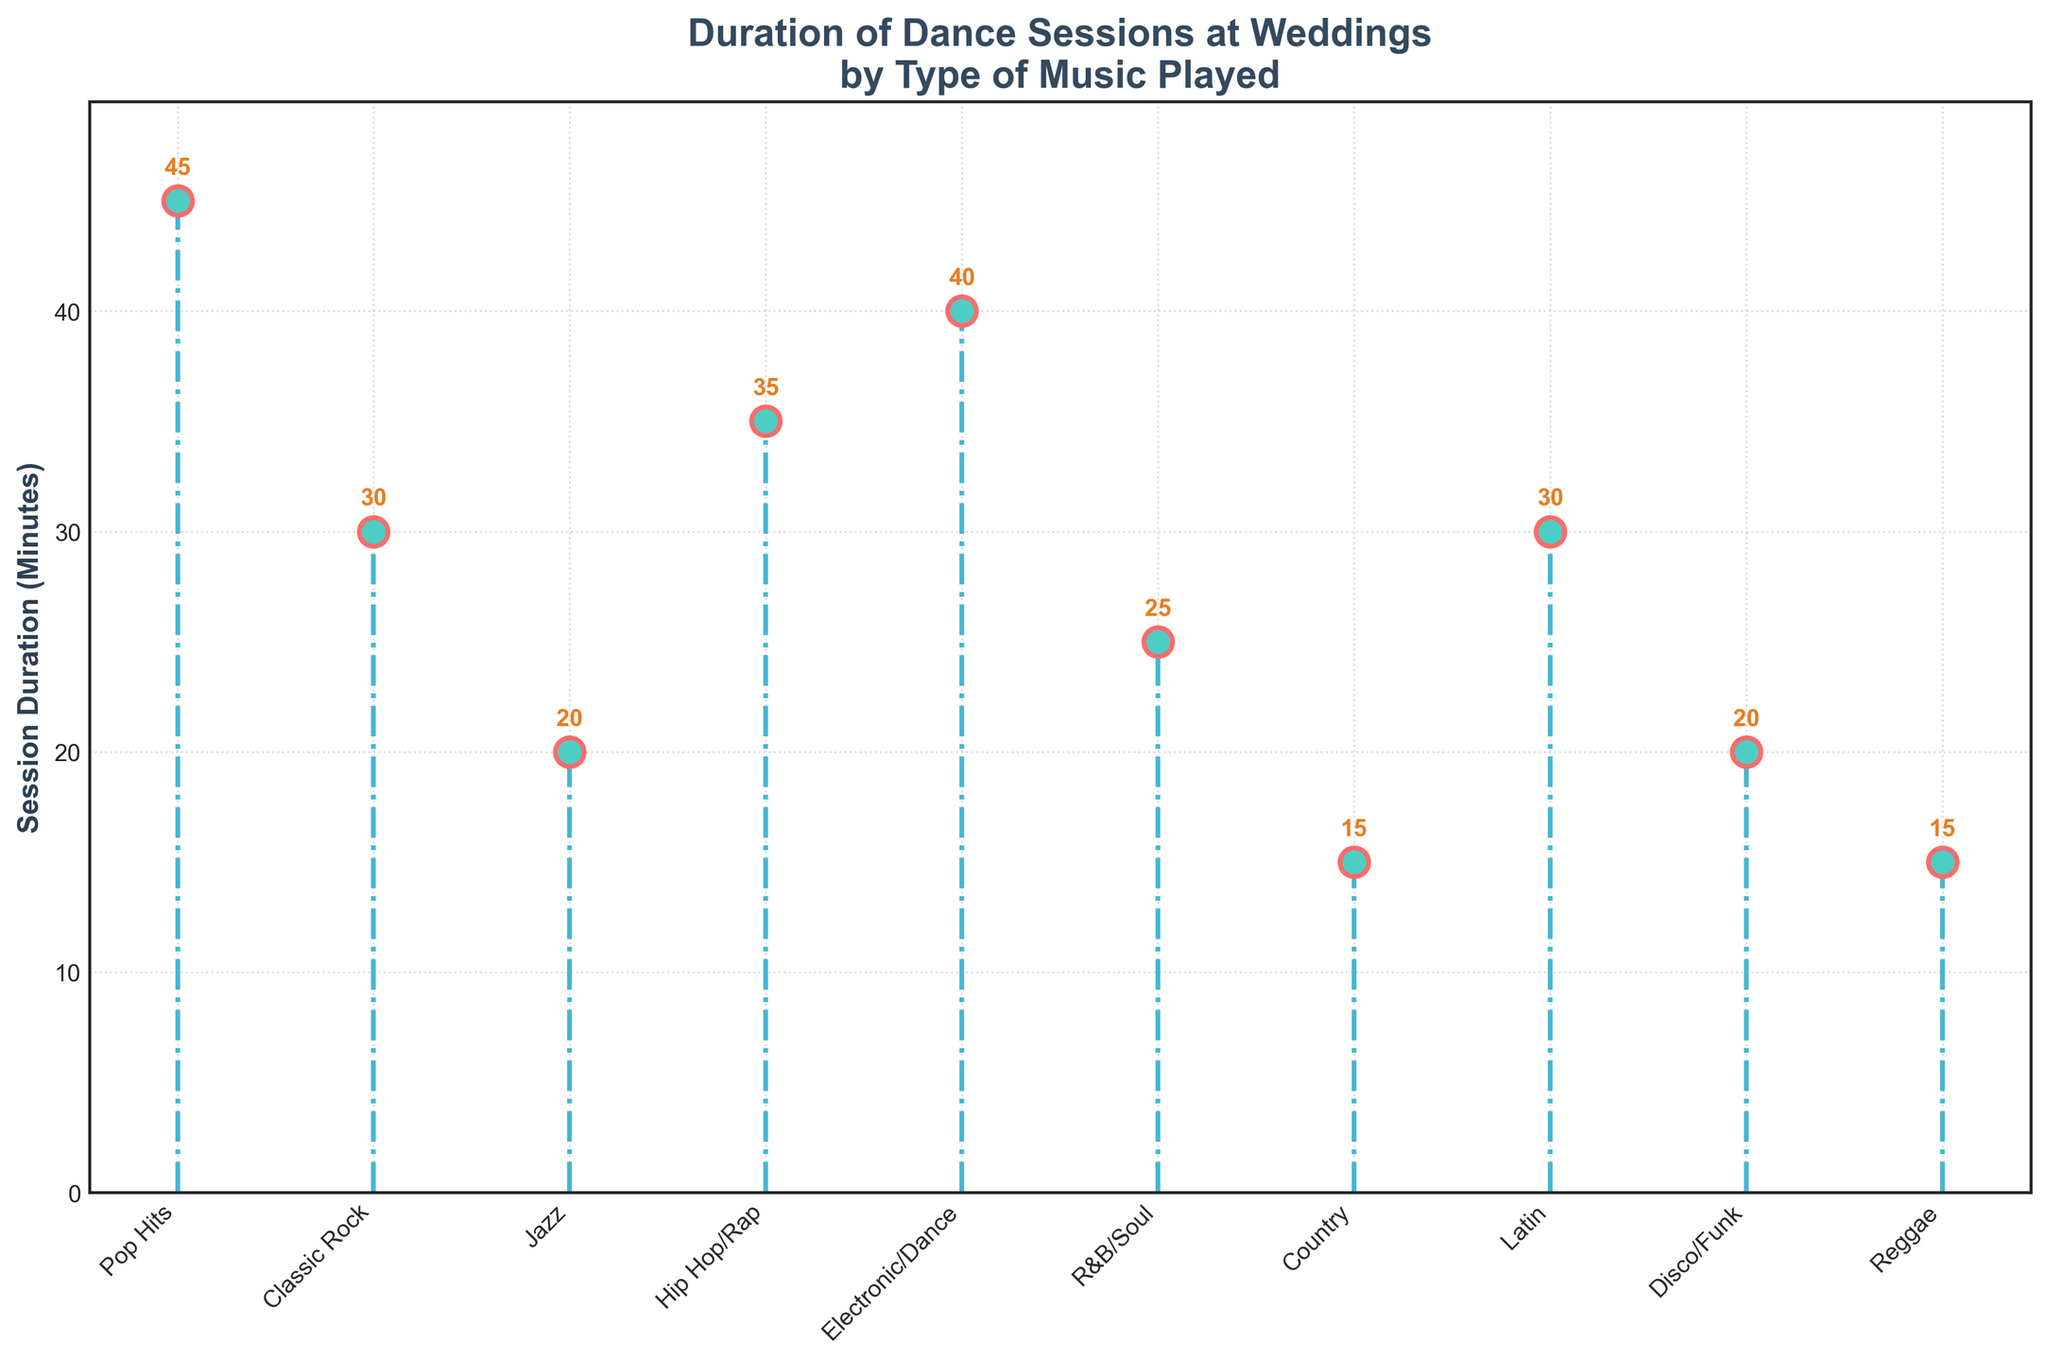what's the title of the figure? The title of a figure provides an overview of what the data represents. It usually appears at the top of the plot and is meant to summarize the main topic. Here, the title is "Duration of Dance Sessions at Weddings by Type of Music Played".
Answer: Duration of Dance Sessions at Weddings by Type of Music Played which type of music has the longest dance session duration? To find the longest session duration, look for the highest point along the y-axis among the data points. Pop Hits has the duration of 45 minutes, which is the highest in the figure.
Answer: Pop Hits how many types of music are compared in the figure? Each distinct data point represents a different type of music. By counting the labels along the x-axis, we can determine there are a total of 10 types of music.
Answer: 10 types what's the average duration of dance sessions for all types of music? Sum up all the session durations and divide by the number of types of music: (45 + 30 + 20 + 35 + 40 + 25 + 15 + 30 + 20 + 15) / 10 = 275 / 10 = 27.5 minutes.
Answer: 27.5 minutes what's the shortest dance session duration and which type of music does it correspond to? To find the shortest session duration, locate the smallest value along the y-axis. The shortest duration is 15 minutes, corresponding to both Country and Reggae music.
Answer: 15 minutes, Country and Reggae how does the duration of Electronic/Dance compare to that of Classic Rock? Compare the y-values for Electronic/Dance and Classic Rock. Electronic/Dance is 40 minutes and Classic Rock is 30 minutes, so Electronic/Dance has a longer duration by 10 minutes.
Answer: Electronic/Dance is longer by 10 minutes what’s the total duration if you combine sessions for Jazz and Disco/Funk? Add the duration values for Jazz and Disco/Funk: 20 minutes for Jazz and 20 minutes for Disco/Funk, so 20 + 20 = 40 minutes.
Answer: 40 minutes which types of music have equal session durations? Compare the y-values to identify any equal durations. Both Jazz and Disco/Funk have a duration of 20 minutes. Similarly, Country and Reggae both have a duration of 15 minutes.
Answer: Jazz and Disco/Funk; Country and Reggae if you wanted to focus on genres with durations of at least 30 minutes, which music types would you select? Identify all genres with session durations of 30 minutes or more: Pop Hits (45), Classic Rock (30), Hip Hop/Rap (35), Electronic/Dance (40), and Latin (30).
Answer: Pop Hits, Classic Rock, Hip Hop/Rap, Electronic/Dance, Latin 